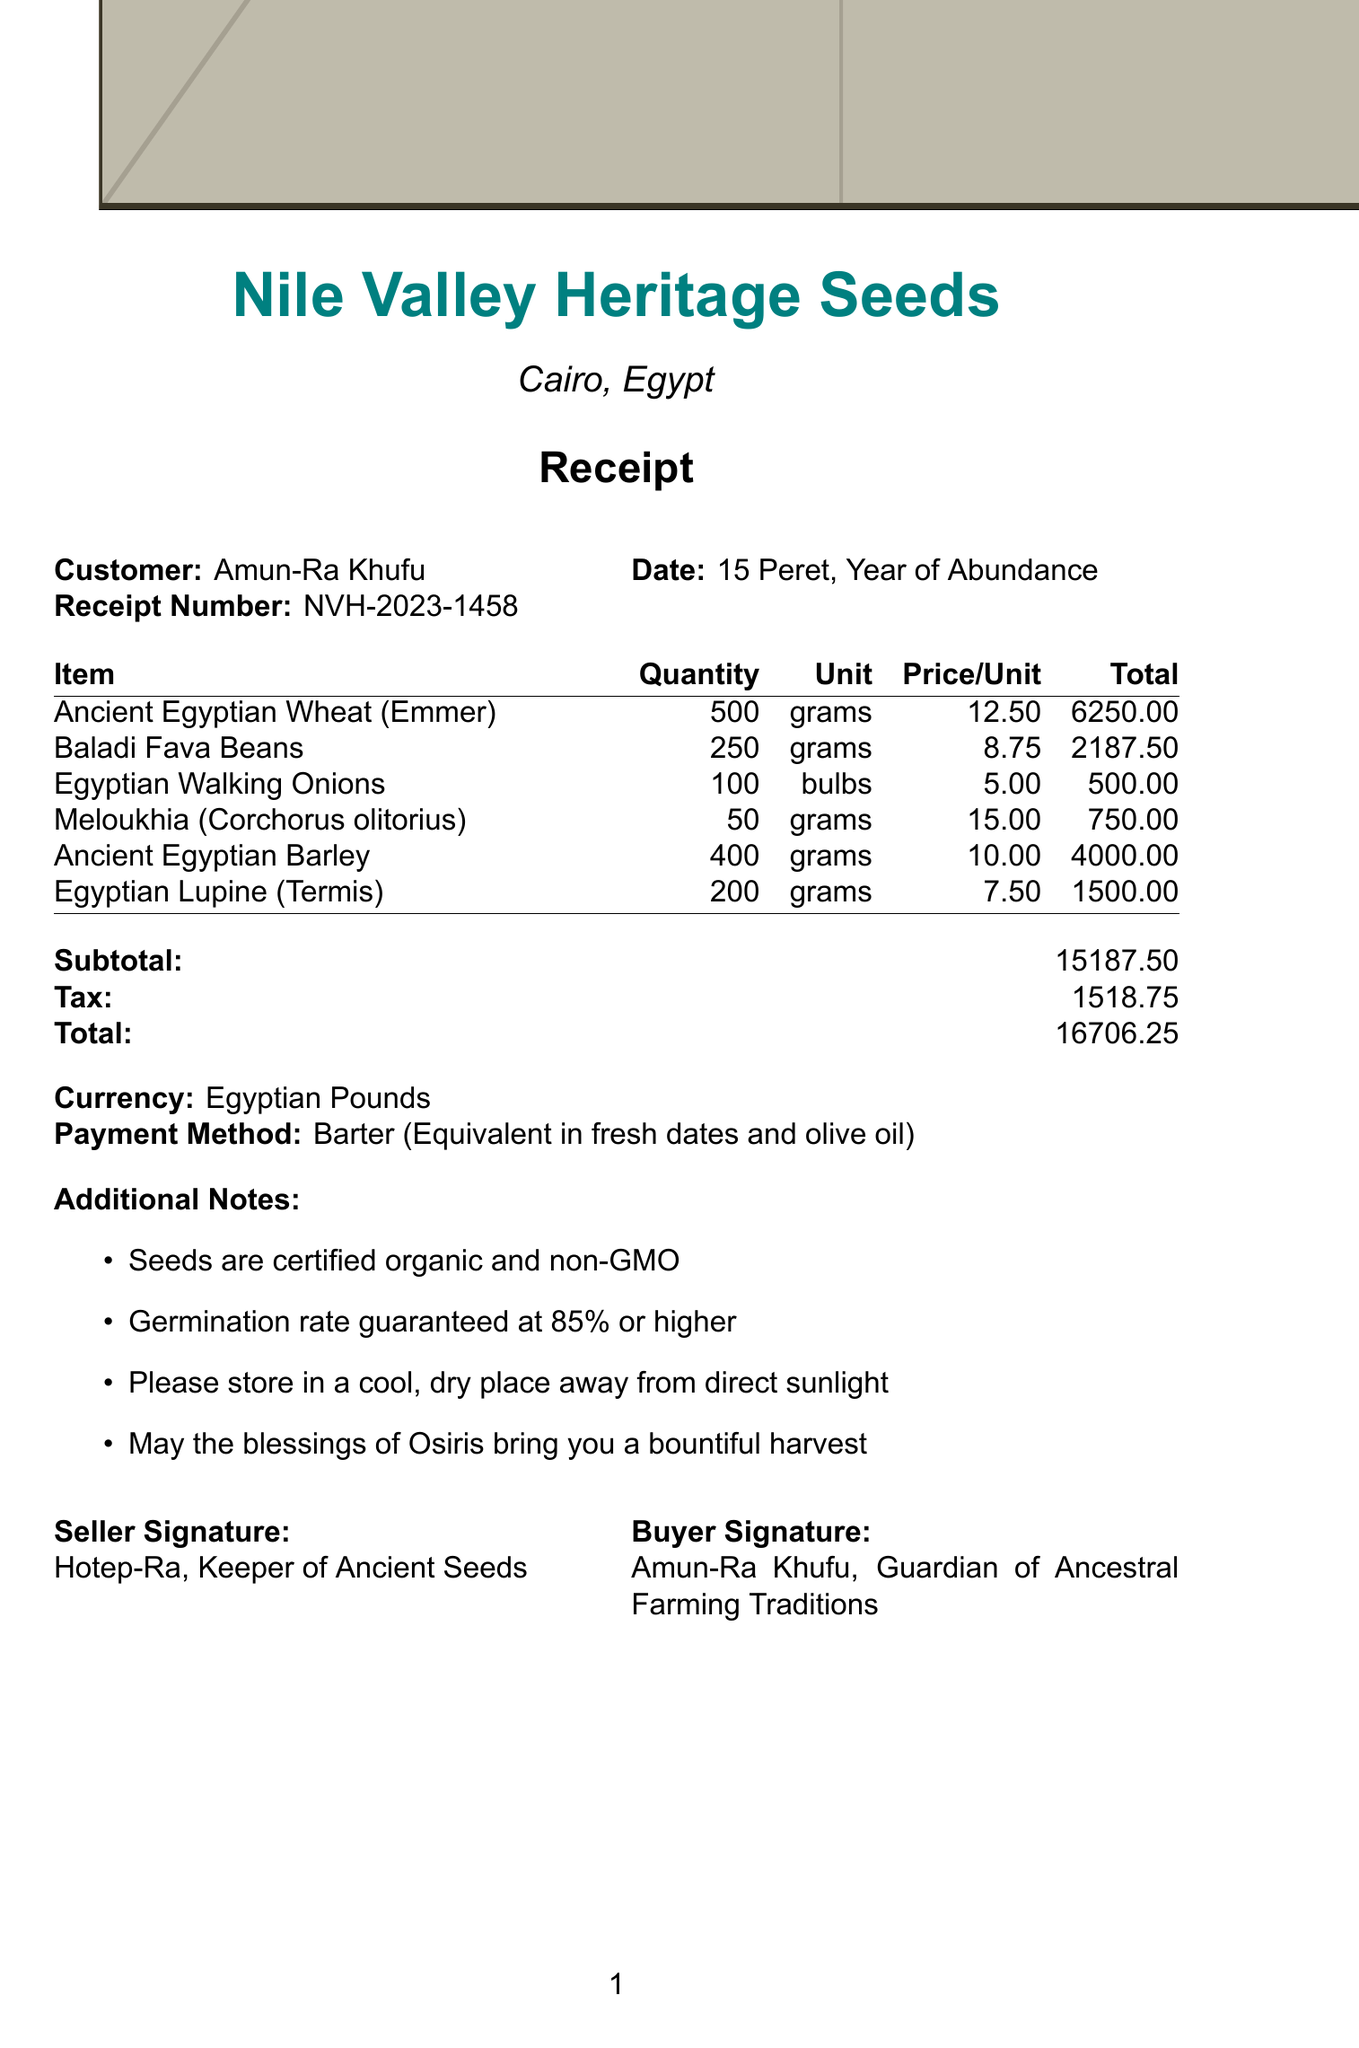what is the store name? The store name is explicitly mentioned at the top of the receipt.
Answer: Nile Valley Heritage Seeds who is the customer? The document lists the name of the customer in the header section.
Answer: Amun-Ra Khufu what is the total amount paid? The total amount can be found in the summary section of the receipt.
Answer: 16706.25 how many grams of Ancient Egyptian Wheat were purchased? The quantity of Ancient Egyptian Wheat is detailed in the itemized list.
Answer: 500 what is the payment method used? The payment method is stated towards the end of the document.
Answer: Barter (Equivalent in fresh dates and olive oil) what was the tax amount? The receipt shows the tax amount in the financial summary section.
Answer: 1518.75 how many varieties of seeds were purchased? The number of seed varieties can be determined by counting the items listed in the document.
Answer: 6 what is the germination rate guarantee? The germination rate guarantee is mentioned in the additional notes section.
Answer: 85% or higher who signed as the seller? The seller's name and title can be found near the bottom of the receipt.
Answer: Hotep-Ra, Keeper of Ancient Seeds 